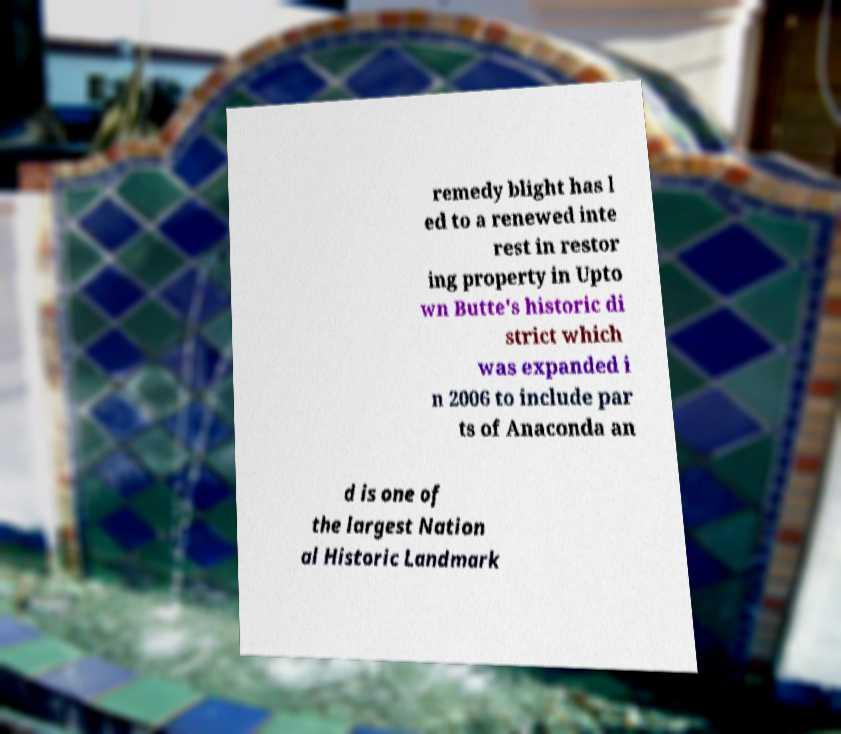There's text embedded in this image that I need extracted. Can you transcribe it verbatim? remedy blight has l ed to a renewed inte rest in restor ing property in Upto wn Butte's historic di strict which was expanded i n 2006 to include par ts of Anaconda an d is one of the largest Nation al Historic Landmark 